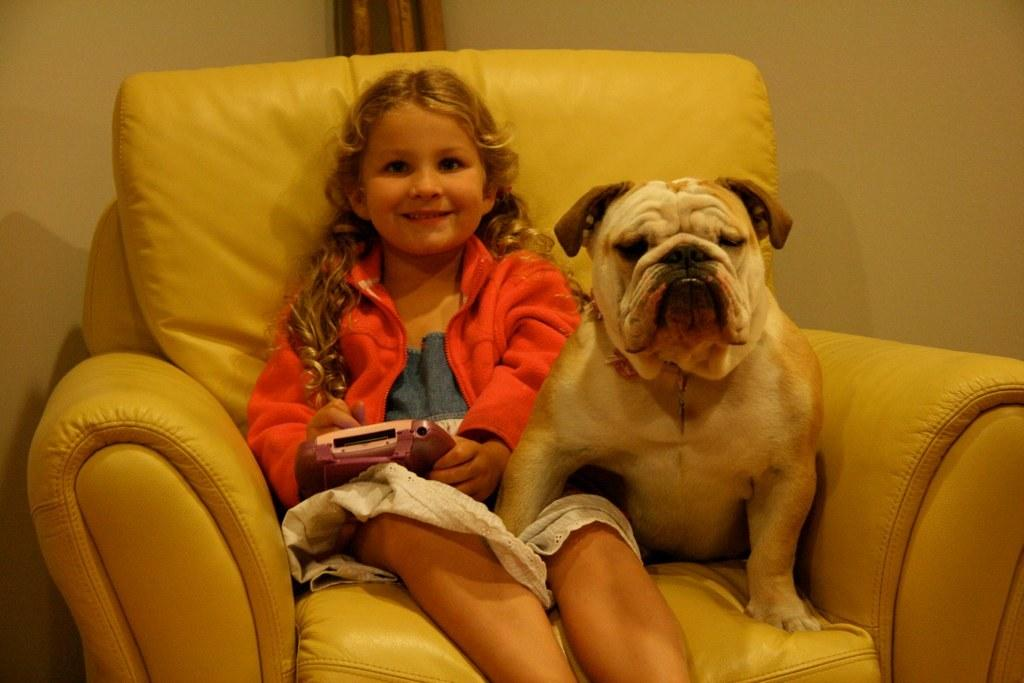What type of furniture is in the image? There is a couch in the image. Who is sitting on the couch? A girl is sitting on the couch. What is the girl holding? The girl is holding an iPod. What other living creature is present in the image? There is a dog next to the girl. What type of attraction is the girl visiting in the image? There is no indication of an attraction in the image; it features a girl sitting on a couch with a dog next to her. Is the girl playing a game of chess with the dog in the image? There is no chess game or any indication of a game being played in the image. 